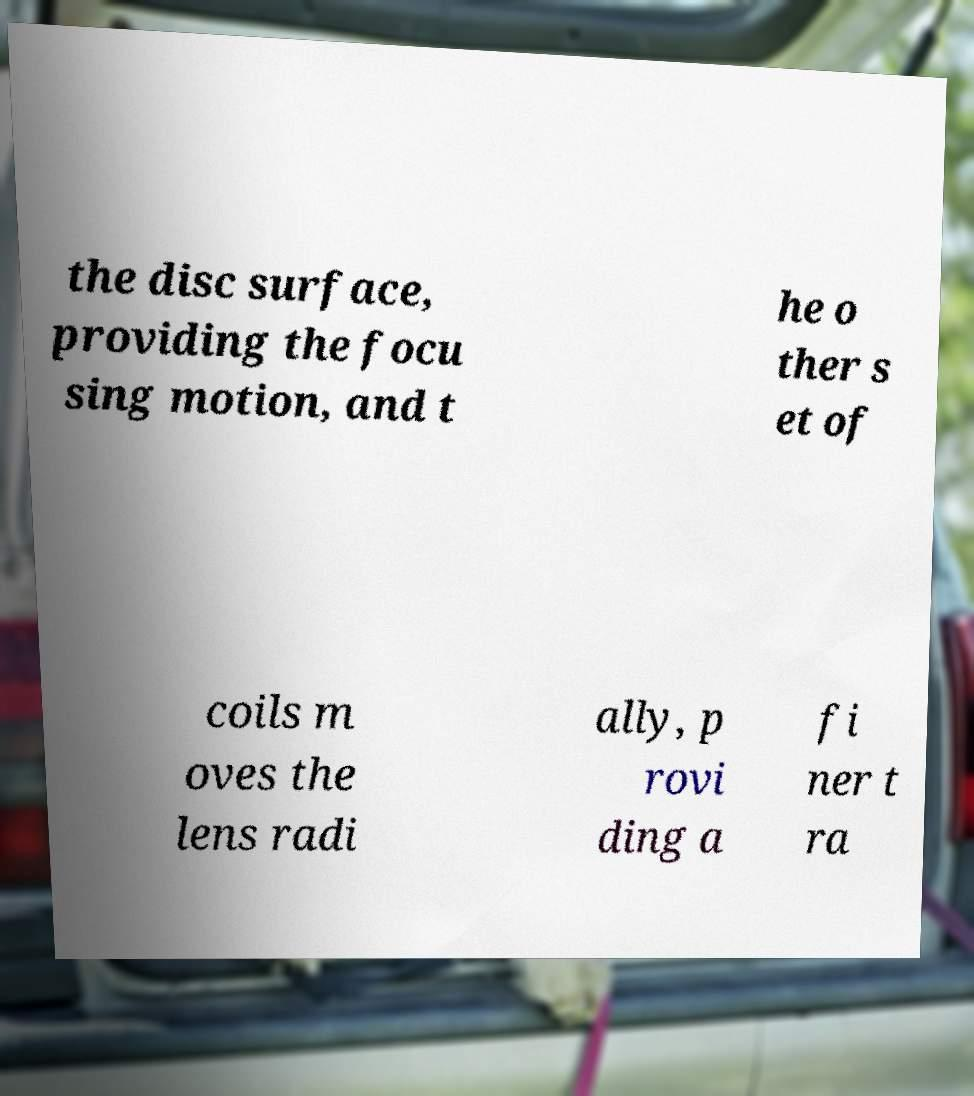There's text embedded in this image that I need extracted. Can you transcribe it verbatim? the disc surface, providing the focu sing motion, and t he o ther s et of coils m oves the lens radi ally, p rovi ding a fi ner t ra 